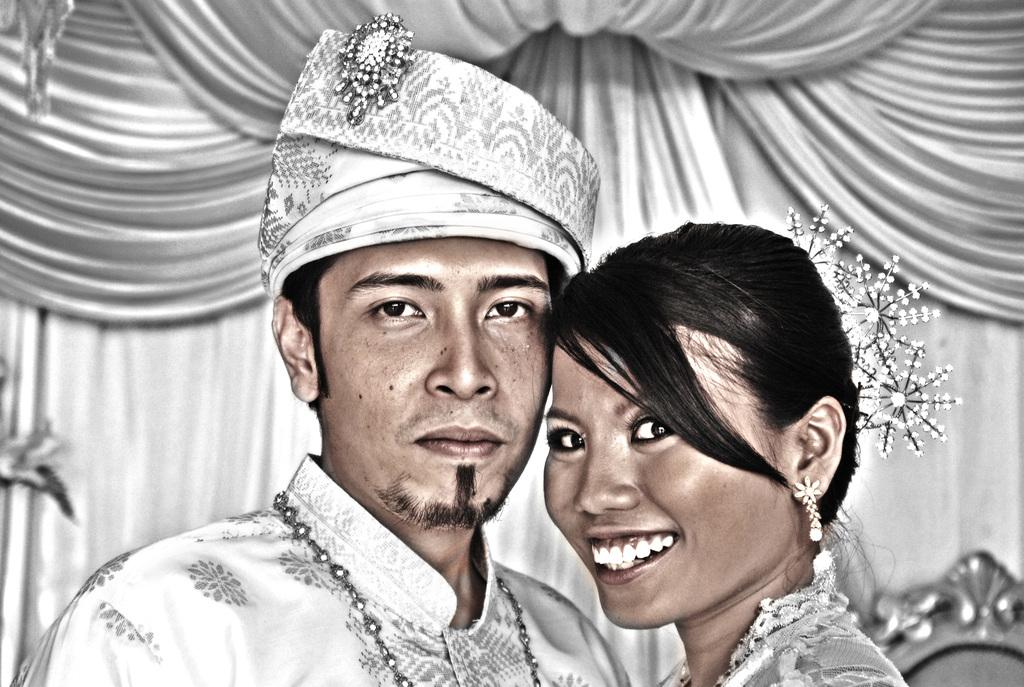How many people are present in the image? There is a man and a woman in the image. What can be seen in the background of the image? There are curtains in the background of the image. What type of card is the man holding in the image? There is no card present in the image; the man is not holding anything. 